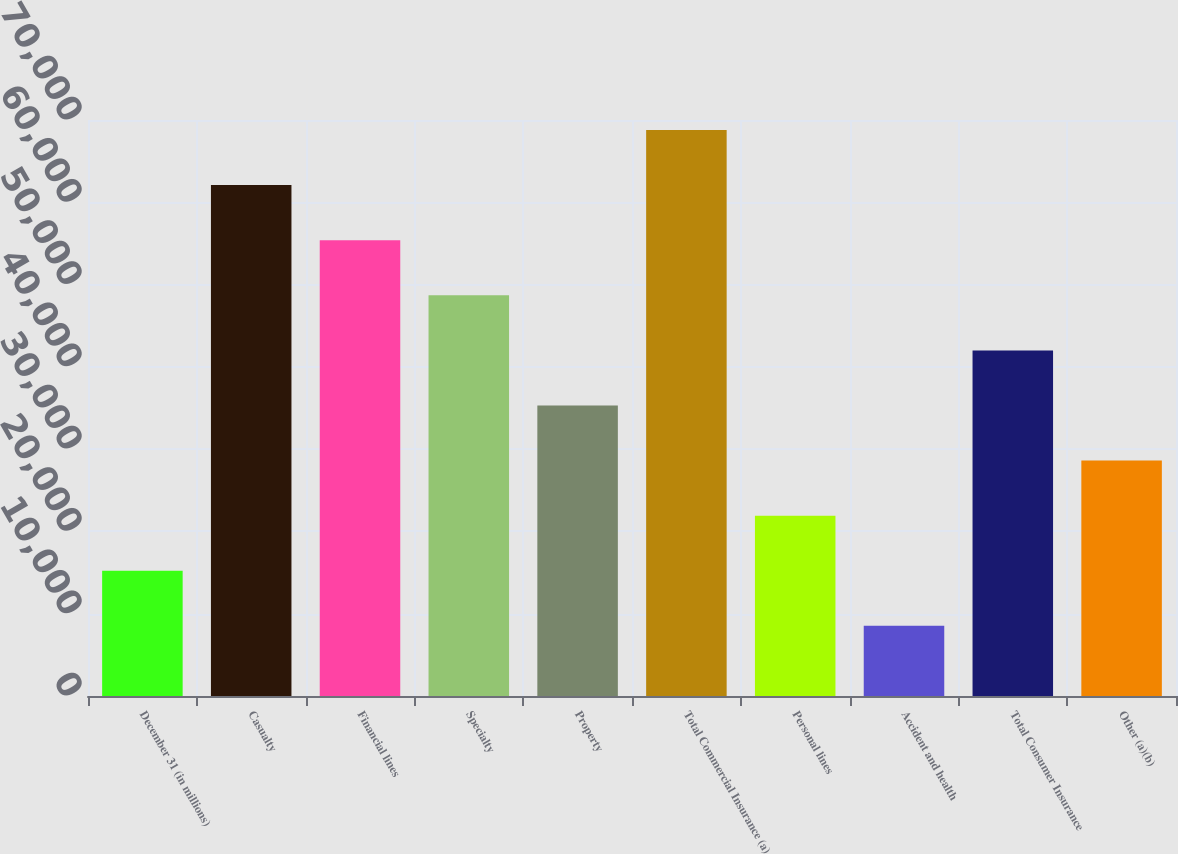Convert chart to OTSL. <chart><loc_0><loc_0><loc_500><loc_500><bar_chart><fcel>December 31 (in millions)<fcel>Casualty<fcel>Financial lines<fcel>Specialty<fcel>Property<fcel>Total Commercial Insurance (a)<fcel>Personal lines<fcel>Accident and health<fcel>Total Consumer Insurance<fcel>Other (a)(b)<nl><fcel>15222.8<fcel>62087.1<fcel>55392.2<fcel>48697.3<fcel>35307.5<fcel>68782<fcel>21917.7<fcel>8527.9<fcel>42002.4<fcel>28612.6<nl></chart> 